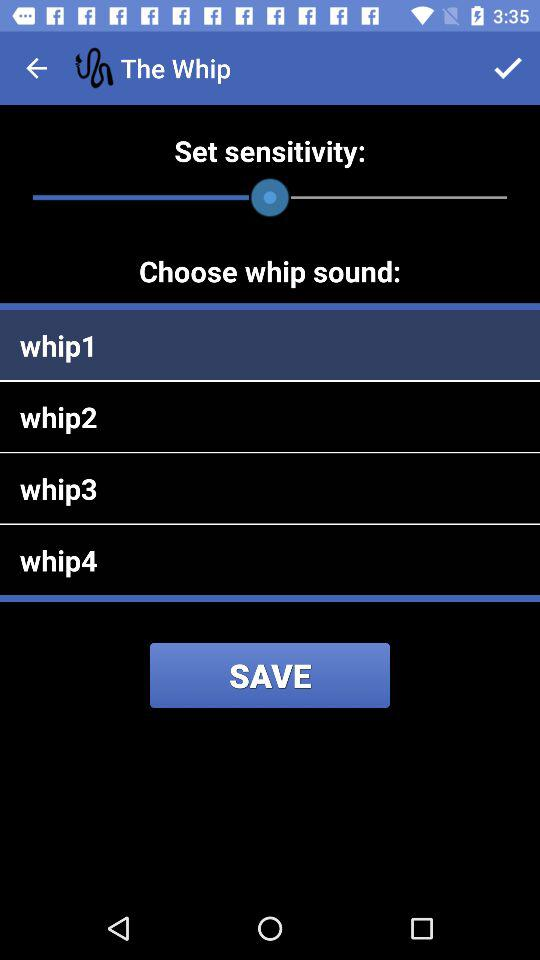How many more whip sounds are available than sensitivity options?
Answer the question using a single word or phrase. 3 